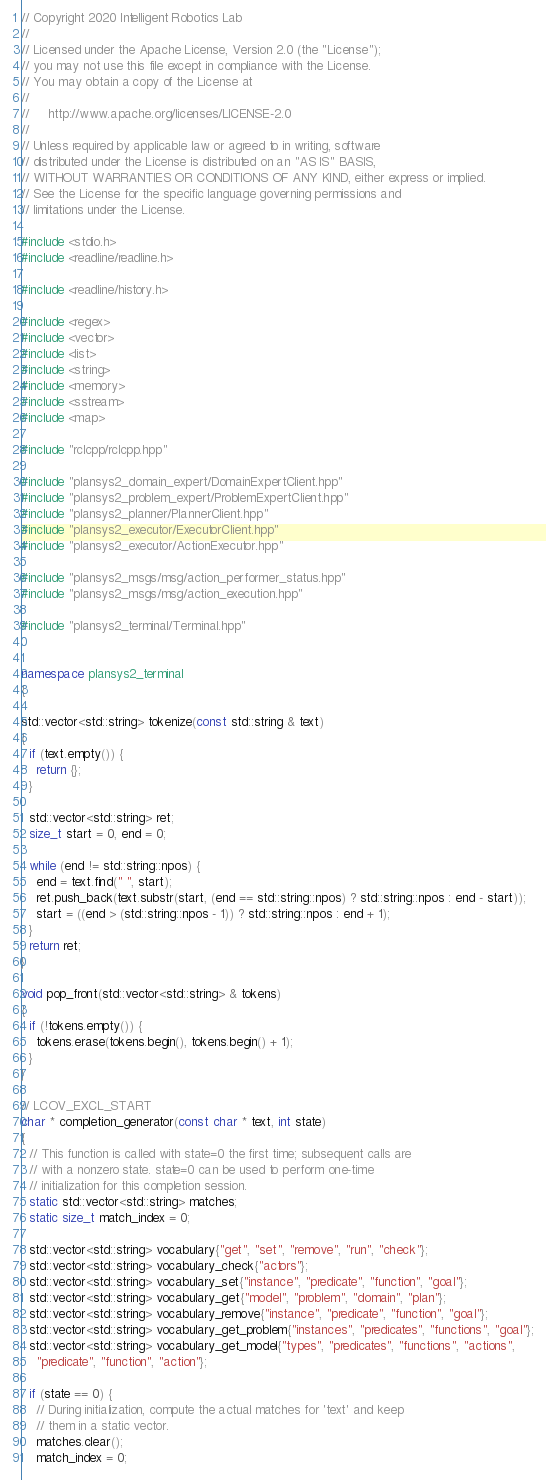Convert code to text. <code><loc_0><loc_0><loc_500><loc_500><_C++_>// Copyright 2020 Intelligent Robotics Lab
//
// Licensed under the Apache License, Version 2.0 (the "License");
// you may not use this file except in compliance with the License.
// You may obtain a copy of the License at
//
//     http://www.apache.org/licenses/LICENSE-2.0
//
// Unless required by applicable law or agreed to in writing, software
// distributed under the License is distributed on an "AS IS" BASIS,
// WITHOUT WARRANTIES OR CONDITIONS OF ANY KIND, either express or implied.
// See the License for the specific language governing permissions and
// limitations under the License.

#include <stdio.h>
#include <readline/readline.h>

#include <readline/history.h>

#include <regex>
#include <vector>
#include <list>
#include <string>
#include <memory>
#include <sstream>
#include <map>

#include "rclcpp/rclcpp.hpp"

#include "plansys2_domain_expert/DomainExpertClient.hpp"
#include "plansys2_problem_expert/ProblemExpertClient.hpp"
#include "plansys2_planner/PlannerClient.hpp"
#include "plansys2_executor/ExecutorClient.hpp"
#include "plansys2_executor/ActionExecutor.hpp"

#include "plansys2_msgs/msg/action_performer_status.hpp"
#include "plansys2_msgs/msg/action_execution.hpp"

#include "plansys2_terminal/Terminal.hpp"


namespace plansys2_terminal
{

std::vector<std::string> tokenize(const std::string & text)
{
  if (text.empty()) {
    return {};
  }

  std::vector<std::string> ret;
  size_t start = 0, end = 0;

  while (end != std::string::npos) {
    end = text.find(" ", start);
    ret.push_back(text.substr(start, (end == std::string::npos) ? std::string::npos : end - start));
    start = ((end > (std::string::npos - 1)) ? std::string::npos : end + 1);
  }
  return ret;
}

void pop_front(std::vector<std::string> & tokens)
{
  if (!tokens.empty()) {
    tokens.erase(tokens.begin(), tokens.begin() + 1);
  }
}

// LCOV_EXCL_START
char * completion_generator(const char * text, int state)
{
  // This function is called with state=0 the first time; subsequent calls are
  // with a nonzero state. state=0 can be used to perform one-time
  // initialization for this completion session.
  static std::vector<std::string> matches;
  static size_t match_index = 0;

  std::vector<std::string> vocabulary{"get", "set", "remove", "run", "check"};
  std::vector<std::string> vocabulary_check{"actors"};
  std::vector<std::string> vocabulary_set{"instance", "predicate", "function", "goal"};
  std::vector<std::string> vocabulary_get{"model", "problem", "domain", "plan"};
  std::vector<std::string> vocabulary_remove{"instance", "predicate", "function", "goal"};
  std::vector<std::string> vocabulary_get_problem{"instances", "predicates", "functions", "goal"};
  std::vector<std::string> vocabulary_get_model{"types", "predicates", "functions", "actions",
    "predicate", "function", "action"};

  if (state == 0) {
    // During initialization, compute the actual matches for 'text' and keep
    // them in a static vector.
    matches.clear();
    match_index = 0;
</code> 